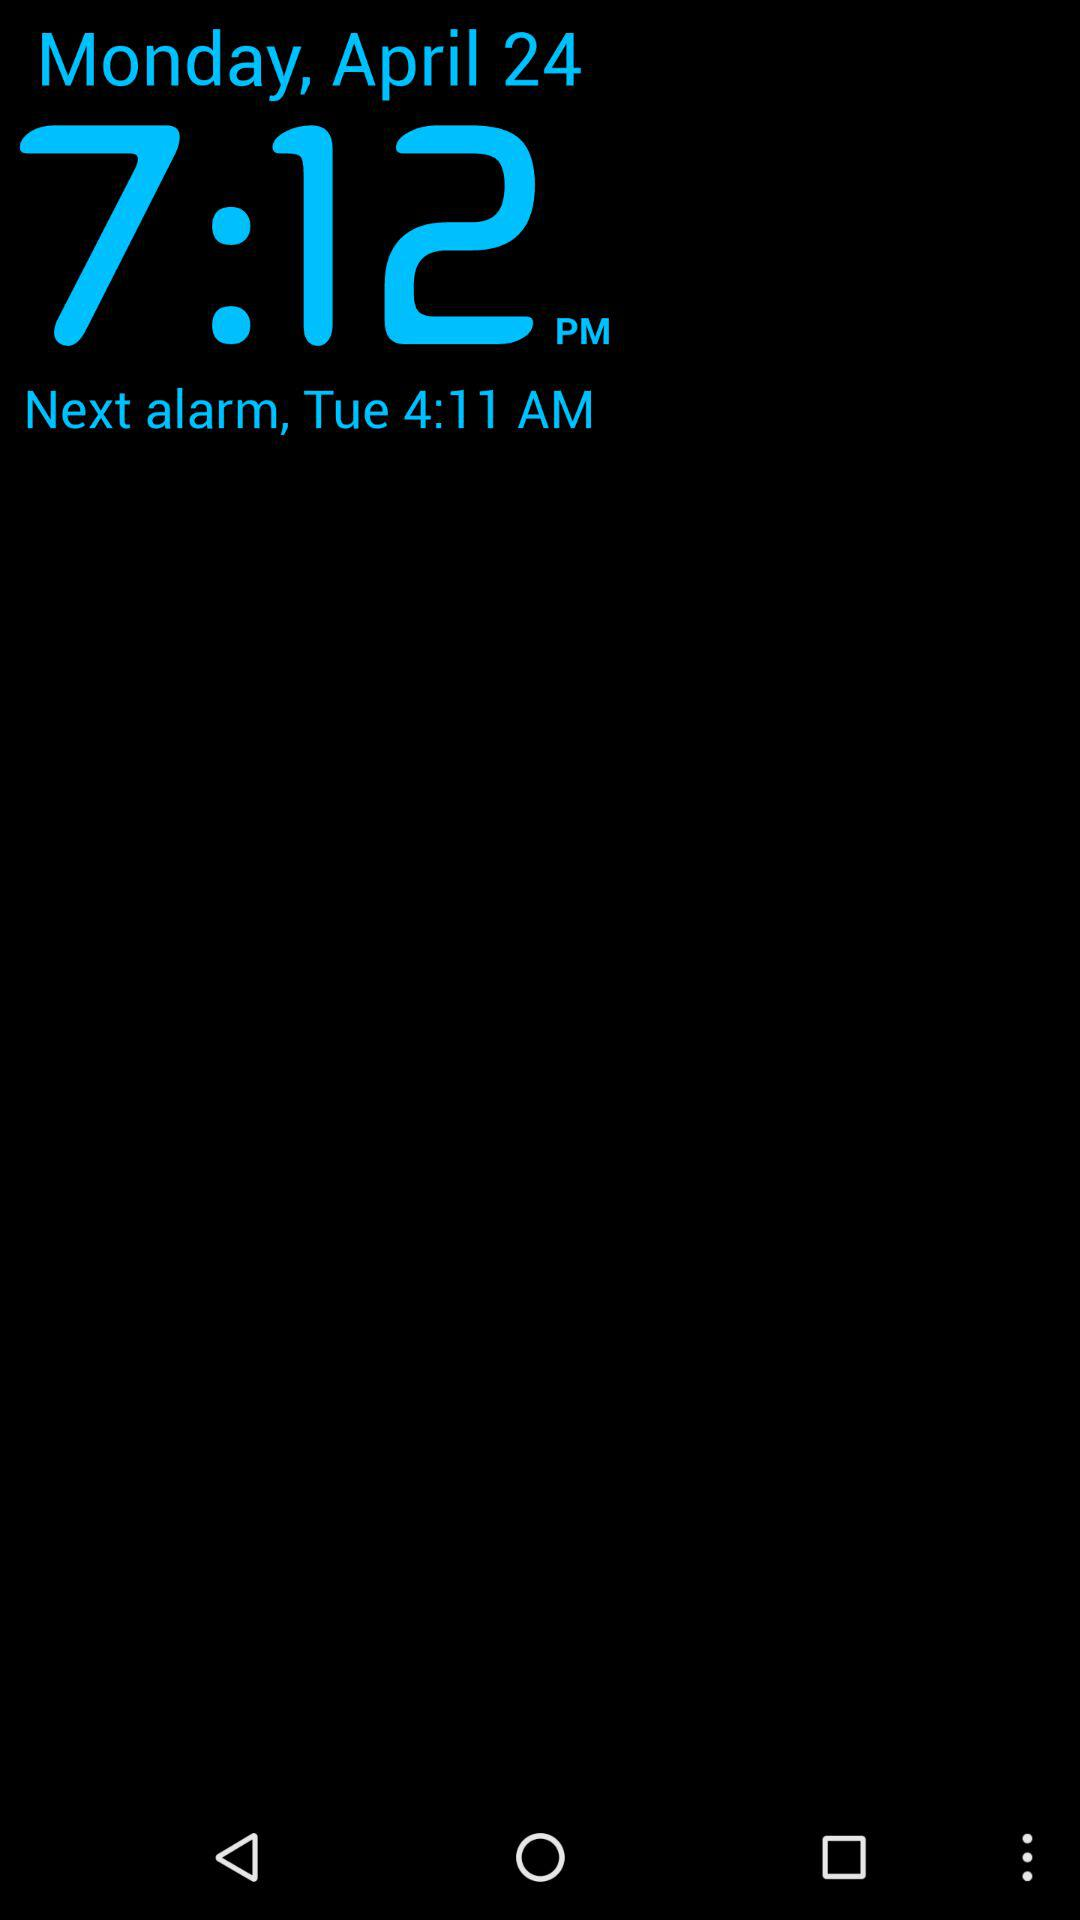What is the day on April 24? The day is Monday. 